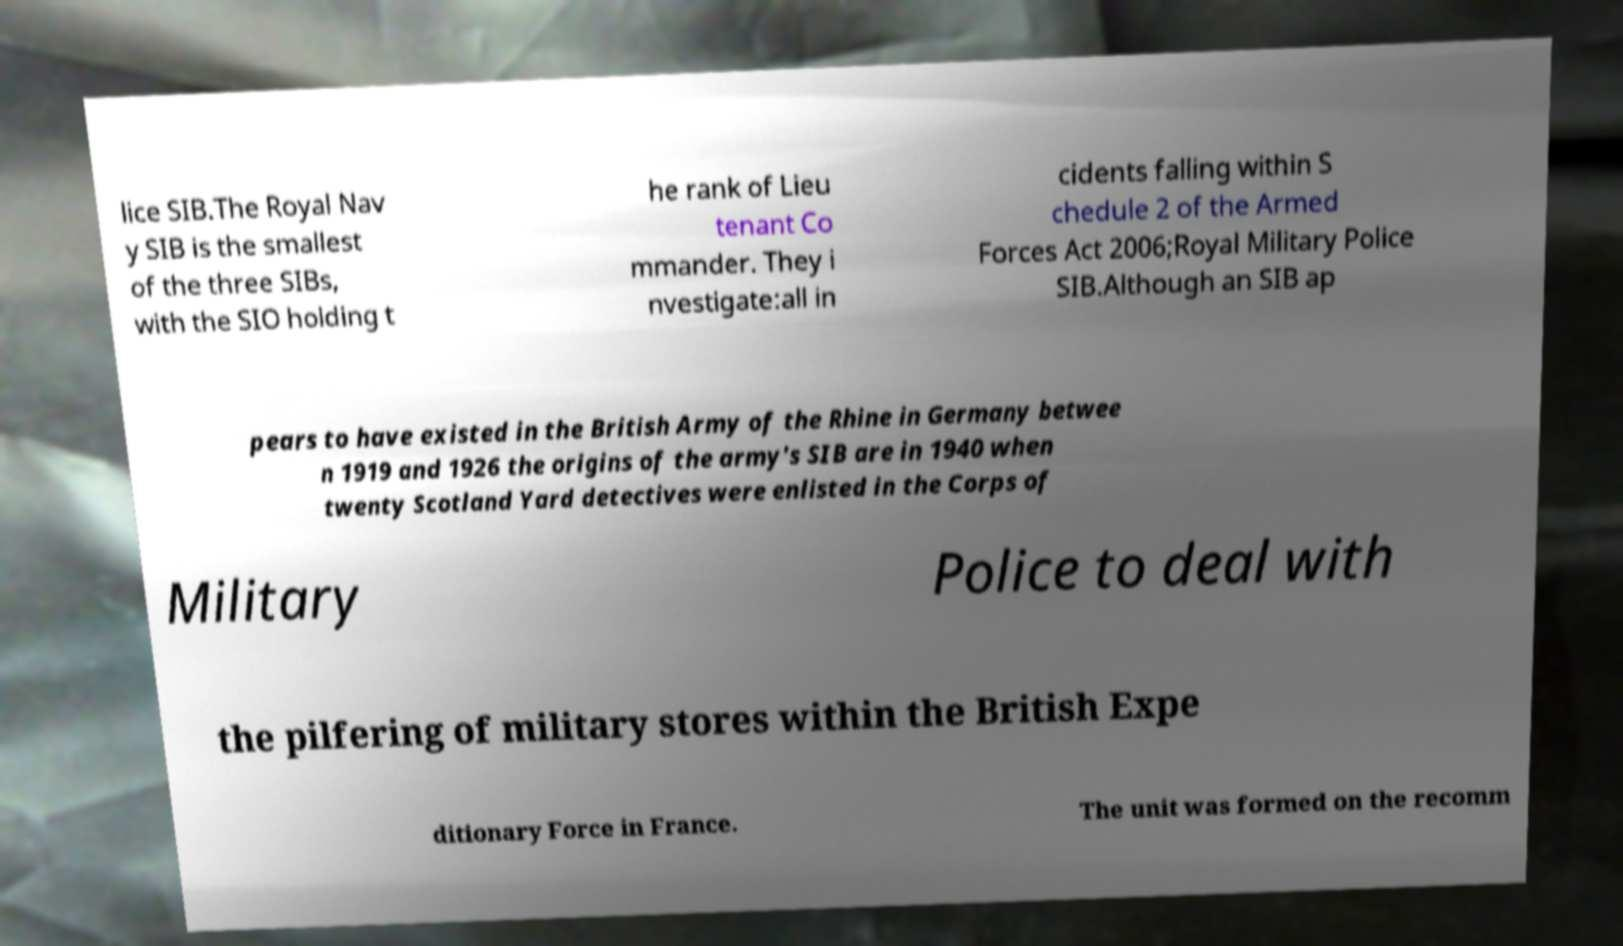Please identify and transcribe the text found in this image. lice SIB.The Royal Nav y SIB is the smallest of the three SIBs, with the SIO holding t he rank of Lieu tenant Co mmander. They i nvestigate:all in cidents falling within S chedule 2 of the Armed Forces Act 2006;Royal Military Police SIB.Although an SIB ap pears to have existed in the British Army of the Rhine in Germany betwee n 1919 and 1926 the origins of the army's SIB are in 1940 when twenty Scotland Yard detectives were enlisted in the Corps of Military Police to deal with the pilfering of military stores within the British Expe ditionary Force in France. The unit was formed on the recomm 